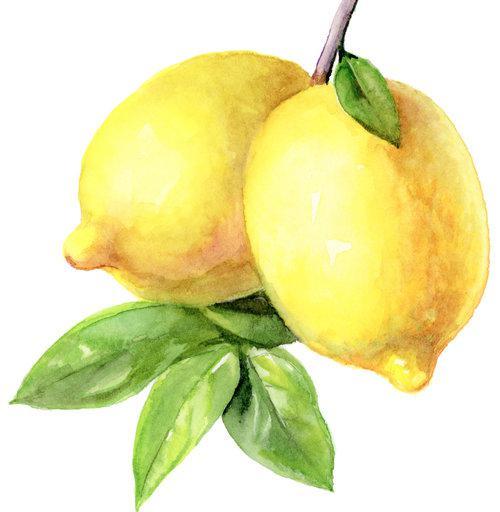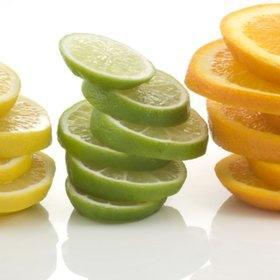The first image is the image on the left, the second image is the image on the right. For the images shown, is this caption "the image on the right contains only one full lemon and a half lemon" true? Answer yes or no. No. 